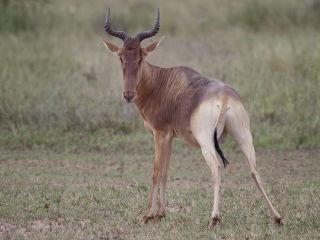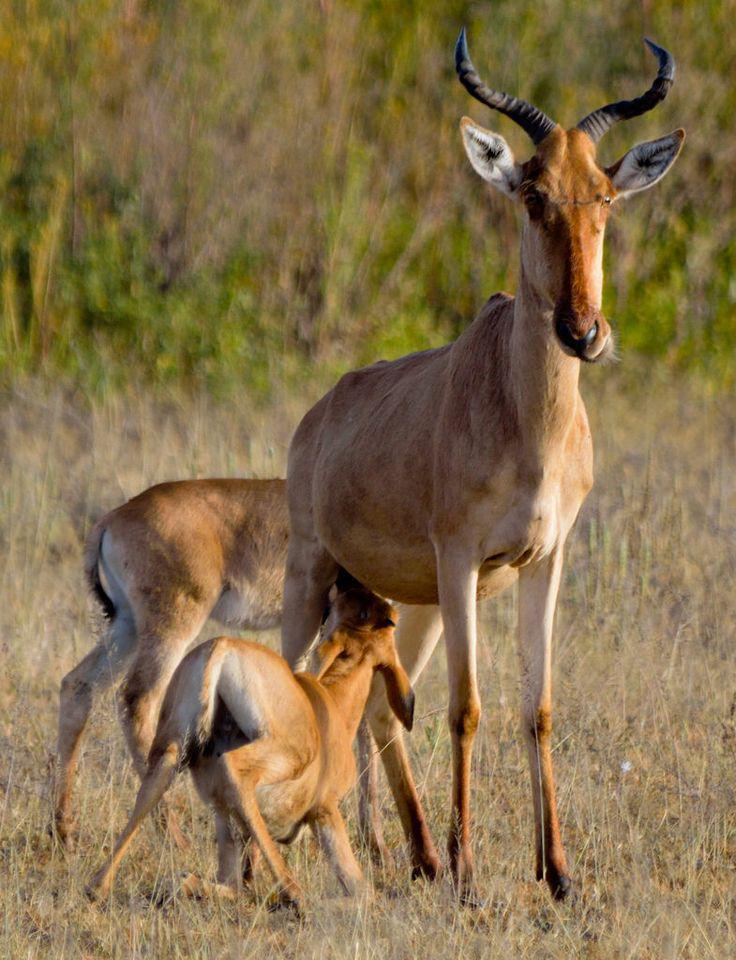The first image is the image on the left, the second image is the image on the right. For the images displayed, is the sentence "Both images feature animals facing the same direction." factually correct? Answer yes or no. No. 